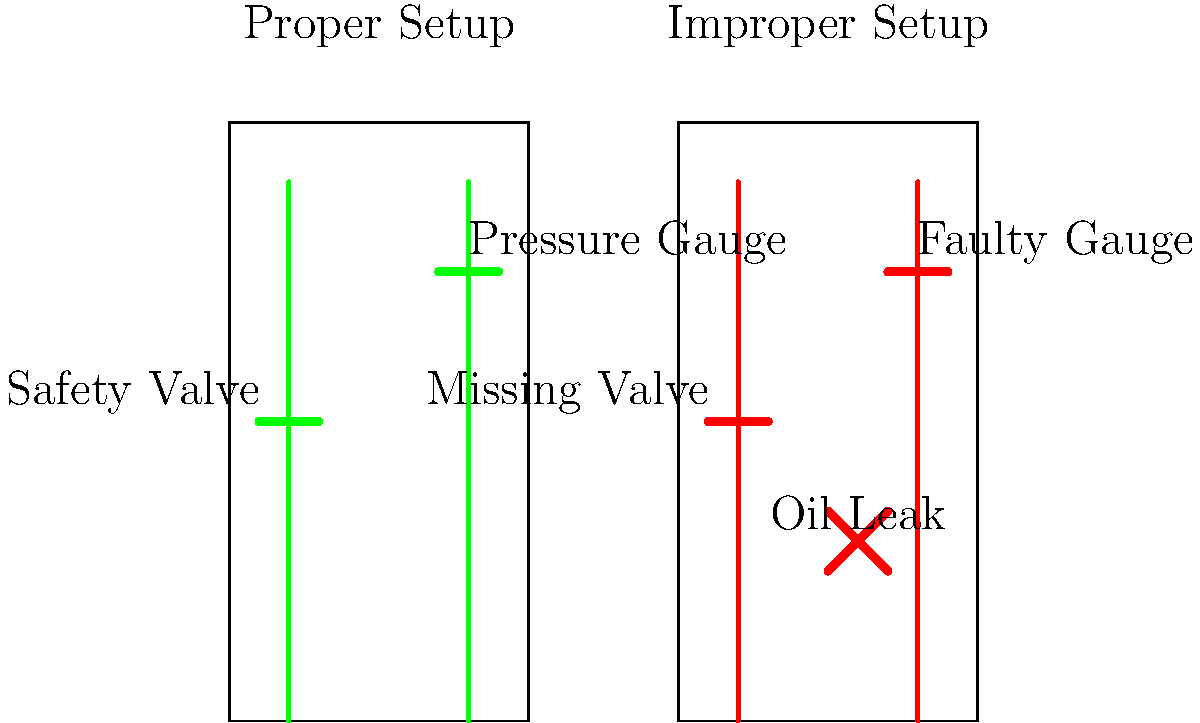Based on your experience as a former oil worker, identify the key safety concerns in the improper setup of the drilling equipment shown in the diagram. How do these issues differ from the proper setup, and what potential risks do they pose to workers and the environment? To answer this question, let's analyze the diagram step-by-step:

1. Proper Setup (Left Side):
   a) The drilling equipment is represented by two vertical green lines.
   b) A safety valve is clearly visible and properly installed.
   c) A pressure gauge is present and correctly positioned.

2. Improper Setup (Right Side):
   a) The drilling equipment is represented by two vertical red lines, indicating issues.
   b) There's a missing safety valve, which is a critical safety concern.
   c) The pressure gauge is labeled as faulty.
   d) An oil leak is depicted near the bottom of the equipment.

3. Key Safety Concerns in Improper Setup:
   a) Missing Safety Valve: This is crucial for controlling pressure and preventing blowouts.
   b) Faulty Pressure Gauge: Without accurate pressure readings, there's a risk of overpressurization.
   c) Oil Leak: This indicates equipment failure and poses environmental and fire hazards.

4. Differences from Proper Setup:
   a) The proper setup has all safety features in place and functioning.
   b) The improper setup lacks essential safety equipment and has visible malfunctions.

5. Potential Risks:
   a) Blowouts due to lack of pressure control (missing safety valve).
   b) Equipment failure from undetected pressure issues (faulty gauge).
   c) Environmental contamination and fire hazards from oil leaks.
   d) Worker injuries or fatalities from potential explosions or equipment failures.
   e) Regulatory violations and potential legal consequences for the company.
Answer: Missing safety valve, faulty pressure gauge, and oil leak, posing risks of blowouts, equipment failure, and environmental hazards. 